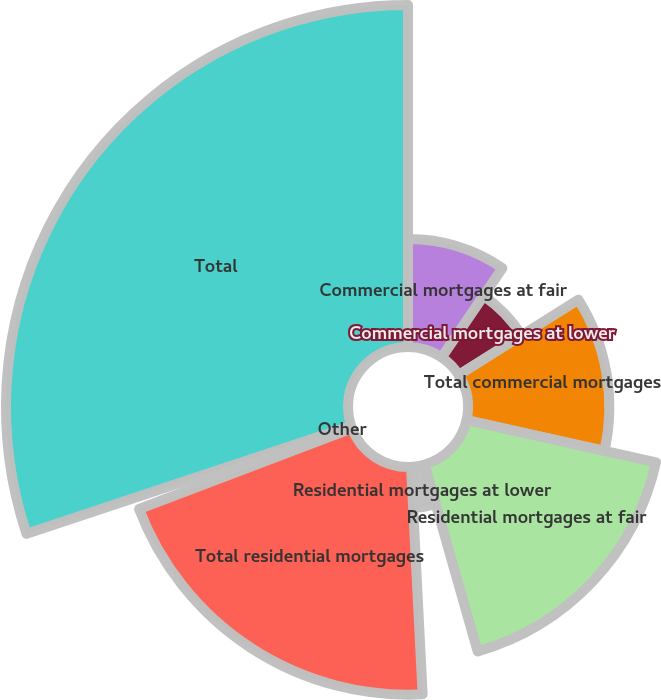<chart> <loc_0><loc_0><loc_500><loc_500><pie_chart><fcel>Commercial mortgages at fair<fcel>Commercial mortgages at lower<fcel>Total commercial mortgages<fcel>Residential mortgages at fair<fcel>Residential mortgages at lower<fcel>Total residential mortgages<fcel>Other<fcel>Total<nl><fcel>9.5%<fcel>6.55%<fcel>12.44%<fcel>17.09%<fcel>3.61%<fcel>20.04%<fcel>0.66%<fcel>30.11%<nl></chart> 